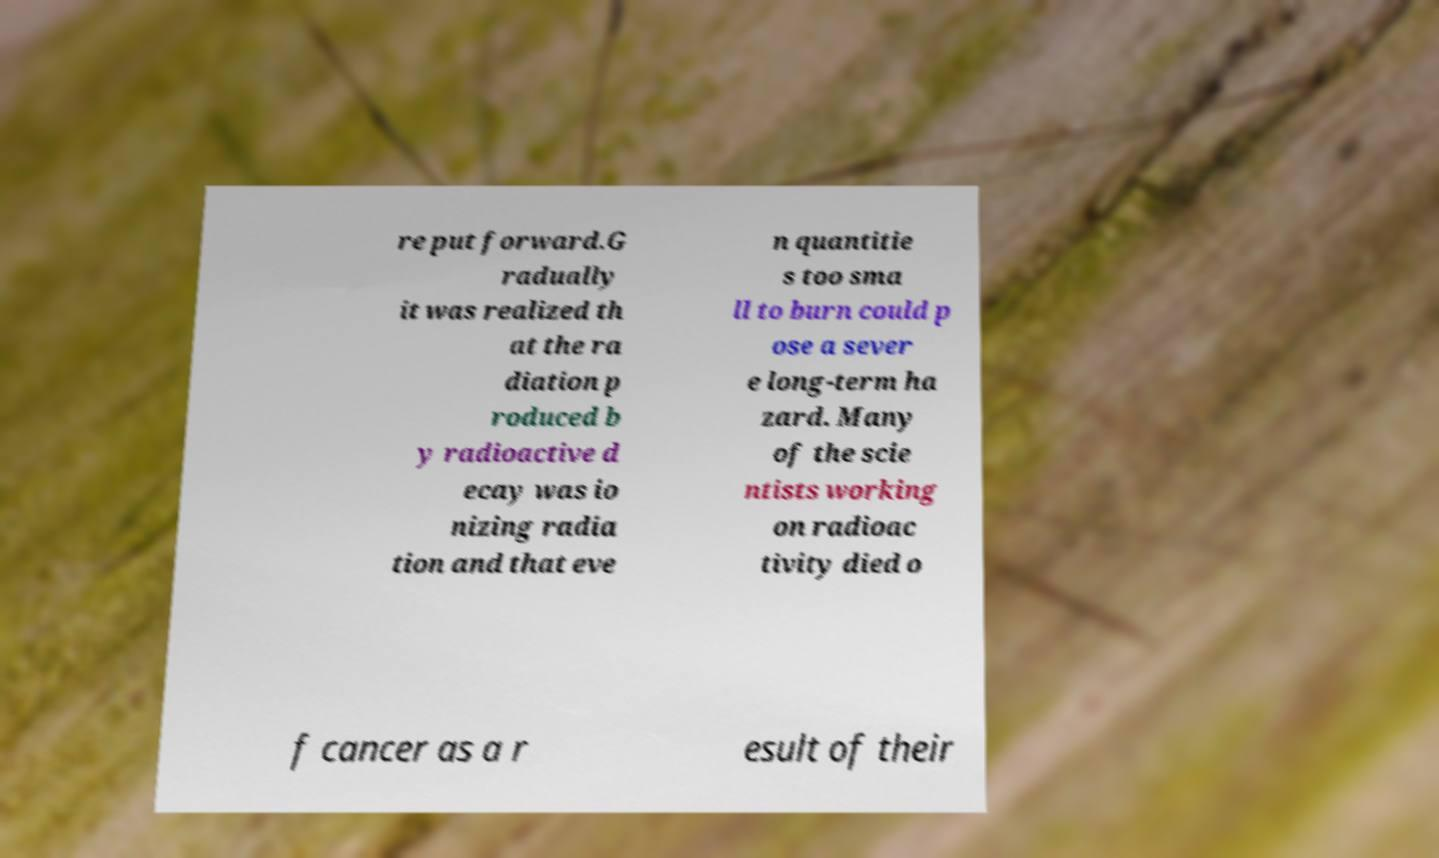Could you extract and type out the text from this image? re put forward.G radually it was realized th at the ra diation p roduced b y radioactive d ecay was io nizing radia tion and that eve n quantitie s too sma ll to burn could p ose a sever e long-term ha zard. Many of the scie ntists working on radioac tivity died o f cancer as a r esult of their 